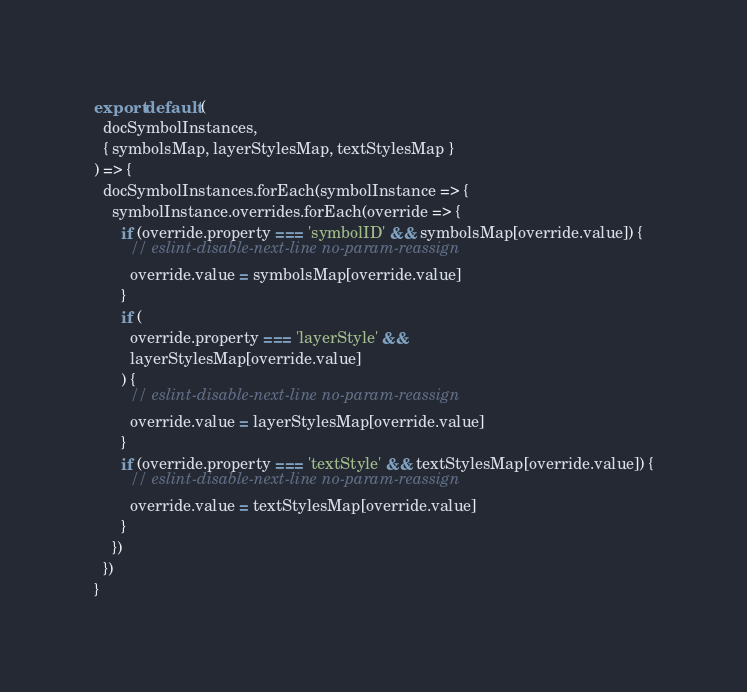Convert code to text. <code><loc_0><loc_0><loc_500><loc_500><_JavaScript_>export default (
  docSymbolInstances,
  { symbolsMap, layerStylesMap, textStylesMap }
) => {
  docSymbolInstances.forEach(symbolInstance => {
    symbolInstance.overrides.forEach(override => {
      if (override.property === 'symbolID' && symbolsMap[override.value]) {
        // eslint-disable-next-line no-param-reassign
        override.value = symbolsMap[override.value]
      }
      if (
        override.property === 'layerStyle' &&
        layerStylesMap[override.value]
      ) {
        // eslint-disable-next-line no-param-reassign
        override.value = layerStylesMap[override.value]
      }
      if (override.property === 'textStyle' && textStylesMap[override.value]) {
        // eslint-disable-next-line no-param-reassign
        override.value = textStylesMap[override.value]
      }
    })
  })
}
</code> 